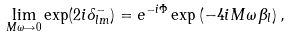<formula> <loc_0><loc_0><loc_500><loc_500>\lim _ { M \omega \rightarrow 0 } \exp ( 2 i \delta _ { l m } ^ { - } ) = e ^ { - i \Phi } \exp \left ( - 4 i M \omega \, \beta _ { l } \right ) ,</formula> 